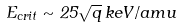<formula> <loc_0><loc_0><loc_500><loc_500>E _ { c r i t } \sim 2 5 \sqrt { q } \, k e V / a m u</formula> 